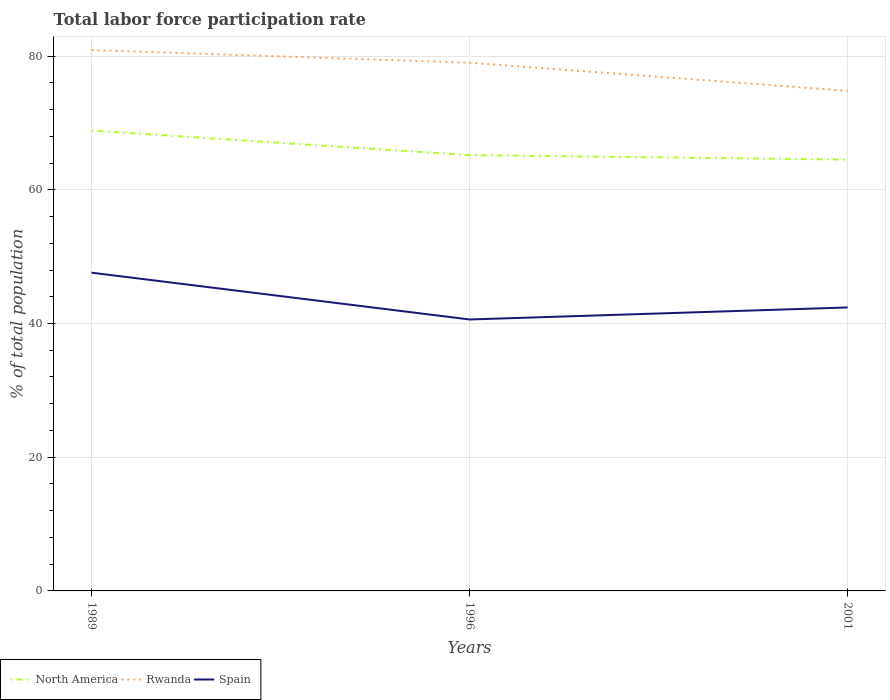How many different coloured lines are there?
Provide a short and direct response. 3. Is the number of lines equal to the number of legend labels?
Provide a short and direct response. Yes. Across all years, what is the maximum total labor force participation rate in North America?
Ensure brevity in your answer.  64.52. What is the total total labor force participation rate in Rwanda in the graph?
Make the answer very short. 6.1. What is the difference between the highest and the lowest total labor force participation rate in North America?
Give a very brief answer. 1. What is the difference between two consecutive major ticks on the Y-axis?
Your answer should be very brief. 20. Are the values on the major ticks of Y-axis written in scientific E-notation?
Offer a terse response. No. Does the graph contain any zero values?
Provide a short and direct response. No. Does the graph contain grids?
Offer a terse response. Yes. How are the legend labels stacked?
Keep it short and to the point. Horizontal. What is the title of the graph?
Give a very brief answer. Total labor force participation rate. What is the label or title of the Y-axis?
Your answer should be compact. % of total population. What is the % of total population in North America in 1989?
Make the answer very short. 68.86. What is the % of total population of Rwanda in 1989?
Offer a very short reply. 80.9. What is the % of total population of Spain in 1989?
Provide a short and direct response. 47.6. What is the % of total population of North America in 1996?
Your response must be concise. 65.18. What is the % of total population in Rwanda in 1996?
Offer a terse response. 79. What is the % of total population in Spain in 1996?
Your response must be concise. 40.6. What is the % of total population in North America in 2001?
Make the answer very short. 64.52. What is the % of total population in Rwanda in 2001?
Make the answer very short. 74.8. What is the % of total population of Spain in 2001?
Your answer should be very brief. 42.4. Across all years, what is the maximum % of total population of North America?
Ensure brevity in your answer.  68.86. Across all years, what is the maximum % of total population of Rwanda?
Your answer should be compact. 80.9. Across all years, what is the maximum % of total population of Spain?
Your response must be concise. 47.6. Across all years, what is the minimum % of total population in North America?
Give a very brief answer. 64.52. Across all years, what is the minimum % of total population of Rwanda?
Provide a succinct answer. 74.8. Across all years, what is the minimum % of total population of Spain?
Make the answer very short. 40.6. What is the total % of total population in North America in the graph?
Ensure brevity in your answer.  198.56. What is the total % of total population in Rwanda in the graph?
Your response must be concise. 234.7. What is the total % of total population of Spain in the graph?
Make the answer very short. 130.6. What is the difference between the % of total population in North America in 1989 and that in 1996?
Offer a terse response. 3.68. What is the difference between the % of total population of Rwanda in 1989 and that in 1996?
Ensure brevity in your answer.  1.9. What is the difference between the % of total population in North America in 1989 and that in 2001?
Offer a terse response. 4.34. What is the difference between the % of total population of North America in 1996 and that in 2001?
Make the answer very short. 0.66. What is the difference between the % of total population in Rwanda in 1996 and that in 2001?
Your response must be concise. 4.2. What is the difference between the % of total population in North America in 1989 and the % of total population in Rwanda in 1996?
Your answer should be compact. -10.14. What is the difference between the % of total population in North America in 1989 and the % of total population in Spain in 1996?
Provide a short and direct response. 28.26. What is the difference between the % of total population in Rwanda in 1989 and the % of total population in Spain in 1996?
Offer a very short reply. 40.3. What is the difference between the % of total population of North America in 1989 and the % of total population of Rwanda in 2001?
Provide a short and direct response. -5.94. What is the difference between the % of total population of North America in 1989 and the % of total population of Spain in 2001?
Provide a short and direct response. 26.46. What is the difference between the % of total population in Rwanda in 1989 and the % of total population in Spain in 2001?
Your answer should be compact. 38.5. What is the difference between the % of total population of North America in 1996 and the % of total population of Rwanda in 2001?
Keep it short and to the point. -9.62. What is the difference between the % of total population in North America in 1996 and the % of total population in Spain in 2001?
Give a very brief answer. 22.78. What is the difference between the % of total population of Rwanda in 1996 and the % of total population of Spain in 2001?
Keep it short and to the point. 36.6. What is the average % of total population of North America per year?
Give a very brief answer. 66.19. What is the average % of total population of Rwanda per year?
Keep it short and to the point. 78.23. What is the average % of total population of Spain per year?
Offer a very short reply. 43.53. In the year 1989, what is the difference between the % of total population in North America and % of total population in Rwanda?
Offer a very short reply. -12.04. In the year 1989, what is the difference between the % of total population of North America and % of total population of Spain?
Your response must be concise. 21.26. In the year 1989, what is the difference between the % of total population of Rwanda and % of total population of Spain?
Your response must be concise. 33.3. In the year 1996, what is the difference between the % of total population of North America and % of total population of Rwanda?
Offer a terse response. -13.82. In the year 1996, what is the difference between the % of total population of North America and % of total population of Spain?
Your answer should be compact. 24.58. In the year 1996, what is the difference between the % of total population in Rwanda and % of total population in Spain?
Your answer should be compact. 38.4. In the year 2001, what is the difference between the % of total population of North America and % of total population of Rwanda?
Ensure brevity in your answer.  -10.28. In the year 2001, what is the difference between the % of total population in North America and % of total population in Spain?
Make the answer very short. 22.12. In the year 2001, what is the difference between the % of total population in Rwanda and % of total population in Spain?
Your answer should be very brief. 32.4. What is the ratio of the % of total population in North America in 1989 to that in 1996?
Make the answer very short. 1.06. What is the ratio of the % of total population in Rwanda in 1989 to that in 1996?
Ensure brevity in your answer.  1.02. What is the ratio of the % of total population of Spain in 1989 to that in 1996?
Give a very brief answer. 1.17. What is the ratio of the % of total population in North America in 1989 to that in 2001?
Your answer should be very brief. 1.07. What is the ratio of the % of total population of Rwanda in 1989 to that in 2001?
Give a very brief answer. 1.08. What is the ratio of the % of total population in Spain in 1989 to that in 2001?
Offer a terse response. 1.12. What is the ratio of the % of total population in North America in 1996 to that in 2001?
Provide a succinct answer. 1.01. What is the ratio of the % of total population in Rwanda in 1996 to that in 2001?
Give a very brief answer. 1.06. What is the ratio of the % of total population of Spain in 1996 to that in 2001?
Give a very brief answer. 0.96. What is the difference between the highest and the second highest % of total population of North America?
Provide a short and direct response. 3.68. What is the difference between the highest and the second highest % of total population in Spain?
Give a very brief answer. 5.2. What is the difference between the highest and the lowest % of total population of North America?
Keep it short and to the point. 4.34. 